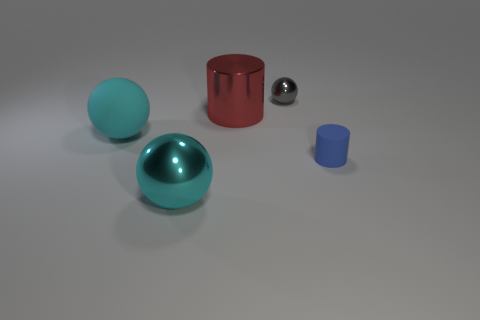What is the color of the small object behind the small thing on the right side of the gray shiny object?
Your answer should be compact. Gray. There is a red shiny object that is behind the shiny sphere in front of the gray ball right of the red metallic object; what shape is it?
Give a very brief answer. Cylinder. What number of cyan balls are the same material as the red object?
Make the answer very short. 1. What number of matte objects are to the right of the big cyan sphere in front of the small matte cylinder?
Offer a terse response. 1. How many yellow blocks are there?
Ensure brevity in your answer.  0. Are the small blue thing and the cyan thing to the left of the cyan metal sphere made of the same material?
Offer a very short reply. Yes. There is a sphere that is in front of the small blue matte cylinder; does it have the same color as the small cylinder?
Make the answer very short. No. What is the thing that is to the right of the large red metal object and in front of the tiny metal thing made of?
Keep it short and to the point. Rubber. What size is the rubber cylinder?
Provide a short and direct response. Small. There is a small ball; is it the same color as the ball that is in front of the large rubber sphere?
Keep it short and to the point. No. 